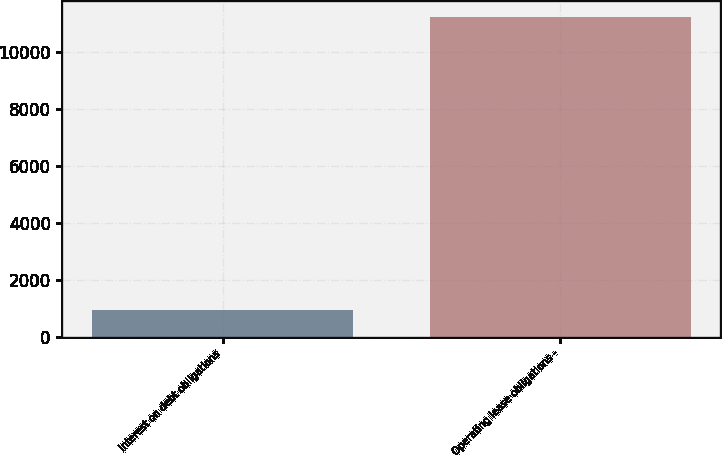Convert chart. <chart><loc_0><loc_0><loc_500><loc_500><bar_chart><fcel>Interest on debt obligations<fcel>Operating lease obligations -<nl><fcel>925<fcel>11258<nl></chart> 